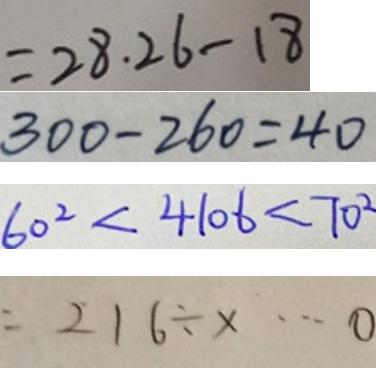Convert formula to latex. <formula><loc_0><loc_0><loc_500><loc_500>= 2 8 . 2 6 - 1 8 
 3 0 0 - 2 6 0 = 4 0 
 6 0 ^ { 2 } < 4 1 0 6 < 7 0 ^ { 2 } 
 = 2 1 6 \div x \cdots 0</formula> 